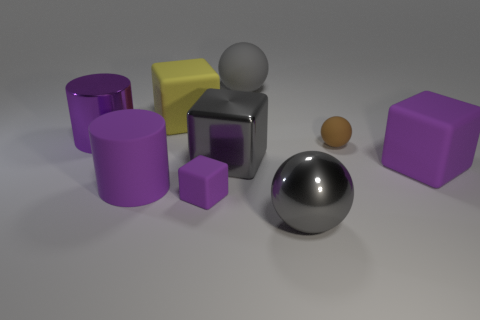There is a metallic cube that is the same size as the gray matte ball; what is its color?
Offer a very short reply. Gray. Is the size of the rubber cylinder the same as the purple metal thing?
Make the answer very short. Yes. There is a large purple metallic object; how many purple metallic things are behind it?
Offer a very short reply. 0. What number of objects are large purple objects left of the big gray rubber object or gray metallic things?
Offer a very short reply. 4. Is the number of small rubber things that are right of the small block greater than the number of cylinders that are on the right side of the small brown matte sphere?
Give a very brief answer. Yes. What is the size of the matte ball that is the same color as the metal block?
Offer a very short reply. Large. There is a gray matte object; does it have the same size as the purple rubber block that is left of the brown ball?
Your answer should be compact. No. What number of cylinders are small things or purple matte objects?
Keep it short and to the point. 1. What is the size of the gray ball that is made of the same material as the tiny brown thing?
Keep it short and to the point. Large. There is a yellow object that is on the left side of the large gray block; is its size the same as the rubber sphere that is in front of the big yellow thing?
Give a very brief answer. No. 